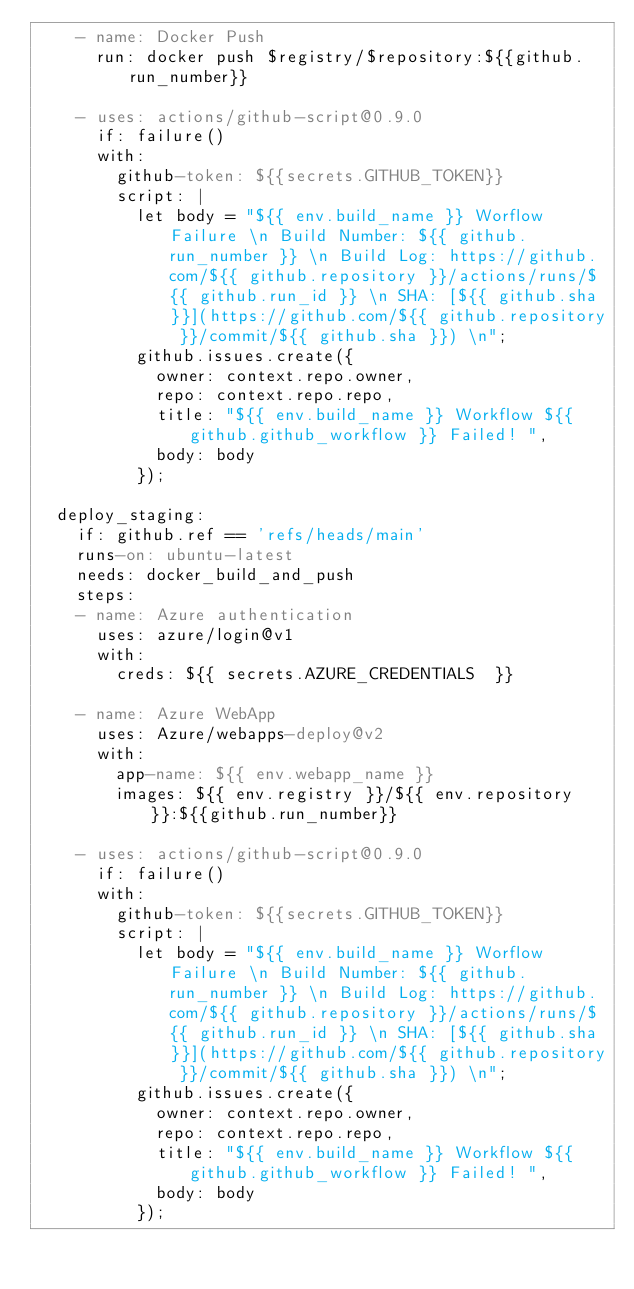<code> <loc_0><loc_0><loc_500><loc_500><_YAML_>    - name: Docker Push
      run: docker push $registry/$repository:${{github.run_number}}  

    - uses: actions/github-script@0.9.0
      if: failure()
      with:
        github-token: ${{secrets.GITHUB_TOKEN}}
        script: |
          let body = "${{ env.build_name }} Worflow Failure \n Build Number: ${{ github.run_number }} \n Build Log: https://github.com/${{ github.repository }}/actions/runs/${{ github.run_id }} \n SHA: [${{ github.sha }}](https://github.com/${{ github.repository }}/commit/${{ github.sha }}) \n";
          github.issues.create({
            owner: context.repo.owner,
            repo: context.repo.repo,
            title: "${{ env.build_name }} Workflow ${{ github.github_workflow }} Failed! ",
            body: body
          });  

  deploy_staging:
    if: github.ref == 'refs/heads/main'
    runs-on: ubuntu-latest
    needs: docker_build_and_push
    steps:
    - name: Azure authentication
      uses: azure/login@v1
      with:
        creds: ${{ secrets.AZURE_CREDENTIALS  }}

    - name: Azure WebApp
      uses: Azure/webapps-deploy@v2
      with:
        app-name: ${{ env.webapp_name }}
        images: ${{ env.registry }}/${{ env.repository }}:${{github.run_number}}

    - uses: actions/github-script@0.9.0
      if: failure()
      with:
        github-token: ${{secrets.GITHUB_TOKEN}}
        script: |
          let body = "${{ env.build_name }} Worflow Failure \n Build Number: ${{ github.run_number }} \n Build Log: https://github.com/${{ github.repository }}/actions/runs/${{ github.run_id }} \n SHA: [${{ github.sha }}](https://github.com/${{ github.repository }}/commit/${{ github.sha }}) \n";
          github.issues.create({
            owner: context.repo.owner,
            repo: context.repo.repo,
            title: "${{ env.build_name }} Workflow ${{ github.github_workflow }} Failed! ",
            body: body
          });</code> 